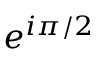<formula> <loc_0><loc_0><loc_500><loc_500>e ^ { i \pi / 2 }</formula> 